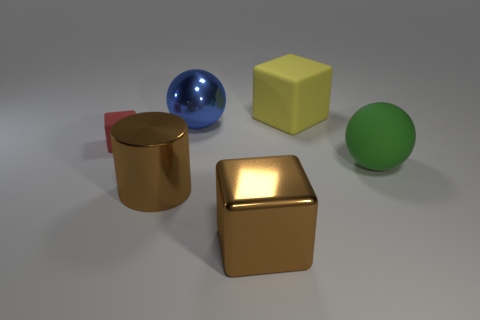Are there fewer large spheres than objects?
Your response must be concise. Yes. There is a matte object to the left of the yellow rubber block; how big is it?
Make the answer very short. Small. What shape is the thing that is right of the big metal block and in front of the small thing?
Your response must be concise. Sphere. There is a red object that is the same shape as the big yellow thing; what is its size?
Make the answer very short. Small. How many big objects have the same material as the tiny thing?
Your answer should be very brief. 2. Do the big metal cube and the big ball that is behind the tiny block have the same color?
Your response must be concise. No. Are there more small matte blocks than cubes?
Offer a terse response. No. The big shiny cylinder has what color?
Ensure brevity in your answer.  Brown. Does the shiny cylinder in front of the tiny cube have the same color as the big shiny cube?
Offer a very short reply. Yes. What number of big metal things are the same color as the metal cylinder?
Your response must be concise. 1. 